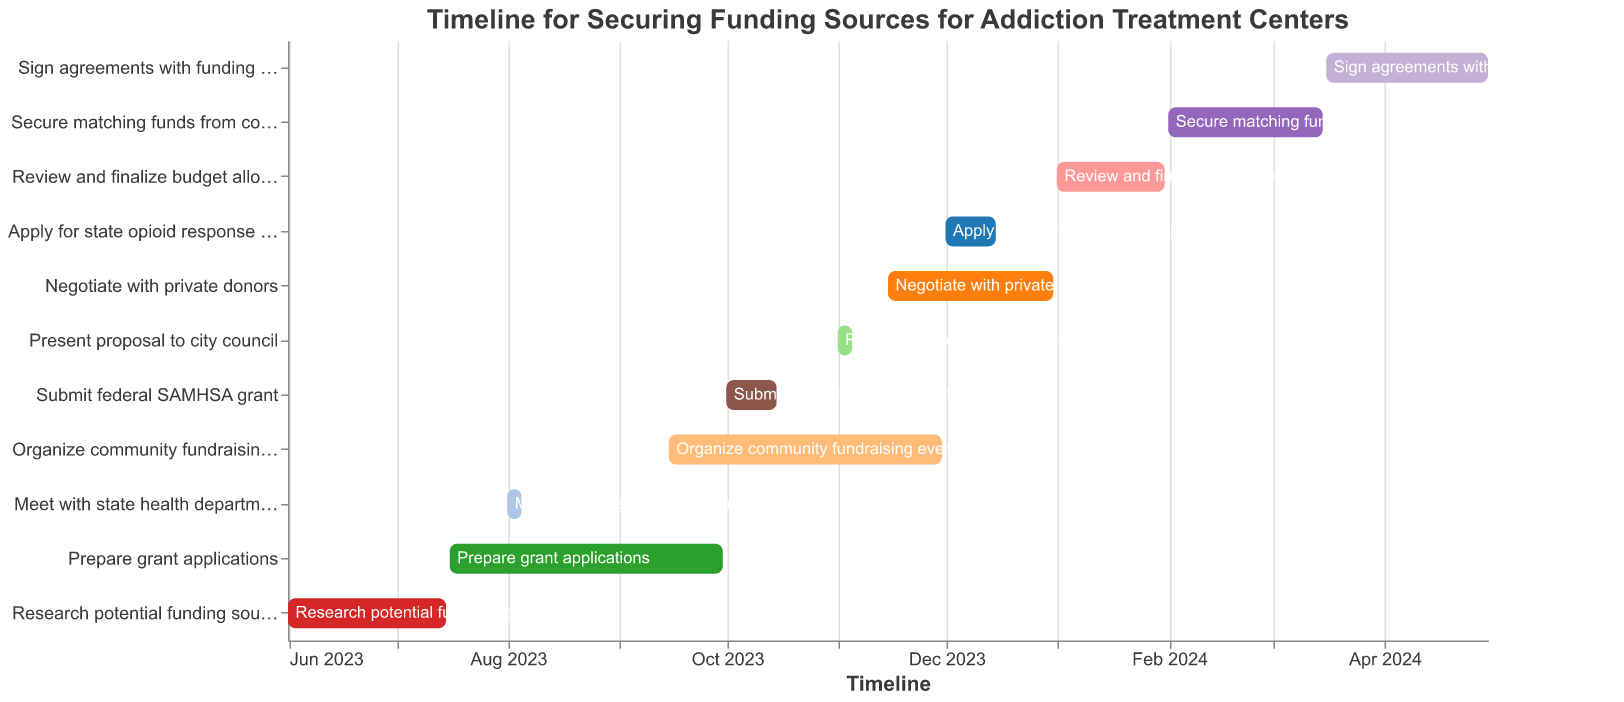What is the title of the Gantt chart? The title is located at the top of the chart and describes the overall purpose of the timeline depicted.
Answer: Timeline for Securing Funding Sources for Addiction Treatment Centers When does the task "Research potential funding sources" end? The ending date is stated in the "End Date" column for the task. Look for "Research potential funding sources" and check its associated end date.
Answer: 2023-07-15 Which task overlaps with "Prepare grant applications"? To find overlapping tasks, see which other bars in the Gantt chart share time periods with "Prepare grant applications," which runs from 2023-07-16 to 2023-09-30.
Answer: Meet with state health department, Organize community fundraising event What is the duration of the task "Secure matching funds from county"? Subtract the start date from the end date for the task "Secure matching funds from county" (2024-02-01 to 2024-03-15).
Answer: 43 days Which task takes place entirely within the month of November 2023? Look for tasks with starting and ending dates that fall within 2023-11-01 to 2023-11-30.
Answer: Present proposal to city council Which task has the longest duration on the Gantt chart? Calculate the duration for each task by subtracting the start date from the end date, then identify the maximum duration.
Answer: Organize community fundraising event What are the start and end dates for "Negotiate with private donors"? Check the Gantt chart for the bar labeled "Negotiate with private donors" and note its start and end dates.
Answer: 2023-11-15 to 2023-12-31 By how many days does "Prepare grant applications" extend beyond "Research potential funding sources"? Find the end date of "Research potential funding sources" and subtract it from the end date of "Prepare grant applications." (2023-09-30 minus 2023-07-15)
Answer: 77 days What task directly follows "Submit federal SAMHSA grant"? Identify the ending date of "Submit federal SAMHSA grant" and see which task begins immediately after.
Answer: Organize community fundraising event How many tasks are planned to be completed by the end of 2023? Count the number of tasks with end dates before or on 2023-12-31.
Answer: 7 tasks 